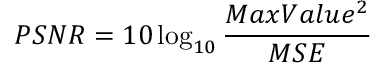<formula> <loc_0><loc_0><loc_500><loc_500>P S N R = 1 0 \log _ { 1 0 } { \frac { M a x V a l u e ^ { 2 } } { M S E } }</formula> 